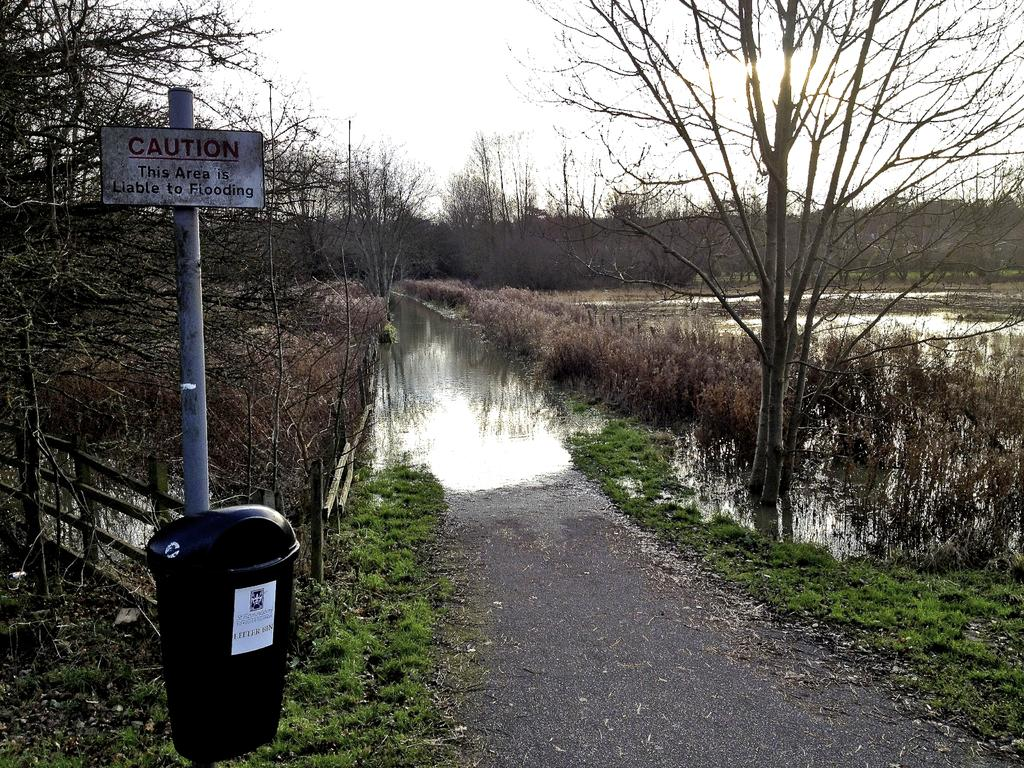<image>
Present a compact description of the photo's key features. A watery area is behind a sign that says "caution" on it. 